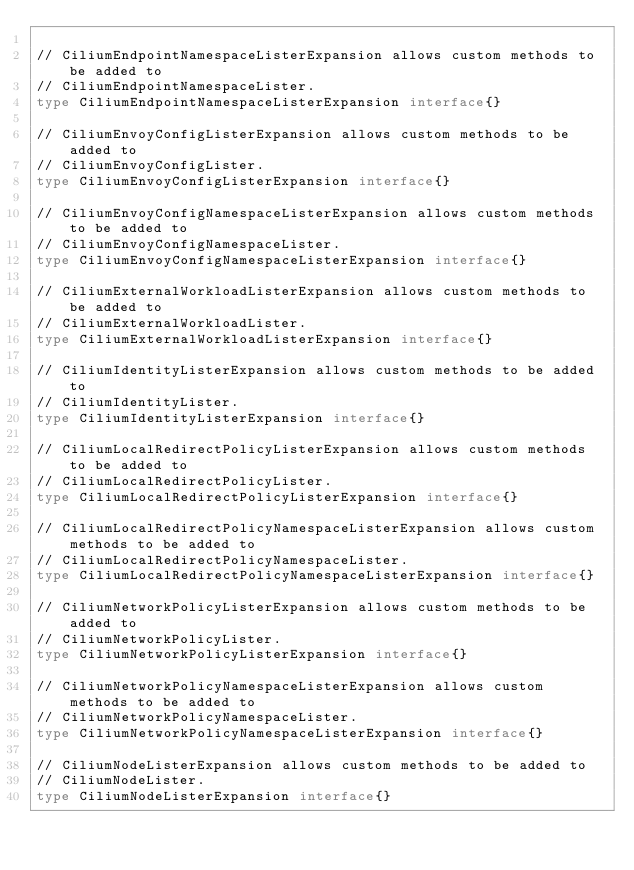<code> <loc_0><loc_0><loc_500><loc_500><_Go_>
// CiliumEndpointNamespaceListerExpansion allows custom methods to be added to
// CiliumEndpointNamespaceLister.
type CiliumEndpointNamespaceListerExpansion interface{}

// CiliumEnvoyConfigListerExpansion allows custom methods to be added to
// CiliumEnvoyConfigLister.
type CiliumEnvoyConfigListerExpansion interface{}

// CiliumEnvoyConfigNamespaceListerExpansion allows custom methods to be added to
// CiliumEnvoyConfigNamespaceLister.
type CiliumEnvoyConfigNamespaceListerExpansion interface{}

// CiliumExternalWorkloadListerExpansion allows custom methods to be added to
// CiliumExternalWorkloadLister.
type CiliumExternalWorkloadListerExpansion interface{}

// CiliumIdentityListerExpansion allows custom methods to be added to
// CiliumIdentityLister.
type CiliumIdentityListerExpansion interface{}

// CiliumLocalRedirectPolicyListerExpansion allows custom methods to be added to
// CiliumLocalRedirectPolicyLister.
type CiliumLocalRedirectPolicyListerExpansion interface{}

// CiliumLocalRedirectPolicyNamespaceListerExpansion allows custom methods to be added to
// CiliumLocalRedirectPolicyNamespaceLister.
type CiliumLocalRedirectPolicyNamespaceListerExpansion interface{}

// CiliumNetworkPolicyListerExpansion allows custom methods to be added to
// CiliumNetworkPolicyLister.
type CiliumNetworkPolicyListerExpansion interface{}

// CiliumNetworkPolicyNamespaceListerExpansion allows custom methods to be added to
// CiliumNetworkPolicyNamespaceLister.
type CiliumNetworkPolicyNamespaceListerExpansion interface{}

// CiliumNodeListerExpansion allows custom methods to be added to
// CiliumNodeLister.
type CiliumNodeListerExpansion interface{}
</code> 